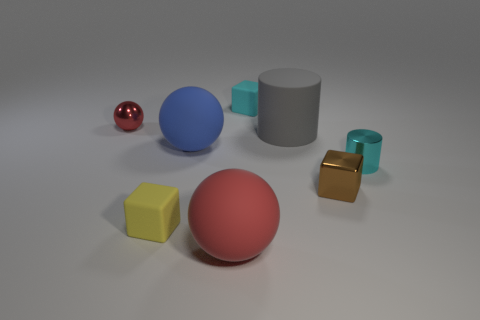The big thing right of the large red rubber ball on the right side of the small yellow rubber thing is what shape?
Your answer should be compact. Cylinder. Is there a green sphere that has the same size as the blue rubber object?
Provide a succinct answer. No. Are there fewer small red metal things than big gray spheres?
Make the answer very short. No. There is a big object that is to the right of the cyan object behind the cyan thing in front of the blue rubber object; what is its shape?
Keep it short and to the point. Cylinder. What number of objects are red spheres in front of the small yellow rubber thing or tiny cyan cylinders on the right side of the tiny shiny sphere?
Offer a very short reply. 2. There is a metallic ball; are there any small cyan things in front of it?
Ensure brevity in your answer.  Yes. What number of things are tiny blocks that are to the left of the small brown metallic thing or small blue rubber blocks?
Your answer should be very brief. 2. How many cyan things are large rubber cylinders or tiny matte objects?
Offer a very short reply. 1. What number of other things are there of the same color as the tiny cylinder?
Make the answer very short. 1. Are there fewer tiny yellow rubber blocks that are behind the small cyan rubber thing than large gray rubber cubes?
Provide a short and direct response. No. 